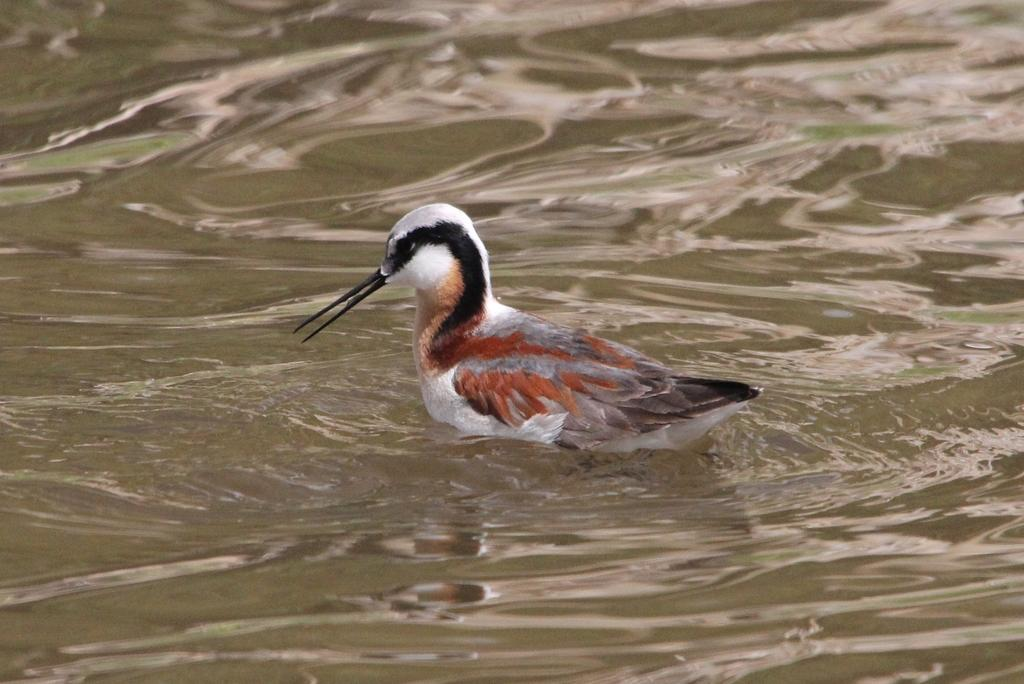What animal is present in the image? There is a duck in the image. Where is the duck located? The duck is in the water. Can you describe the position of the duck in the image? The duck is in the foreground area of the image. What type of balloon can be seen floating in the water with the duck? There is no balloon present in the image; it only features a duck in the water. 